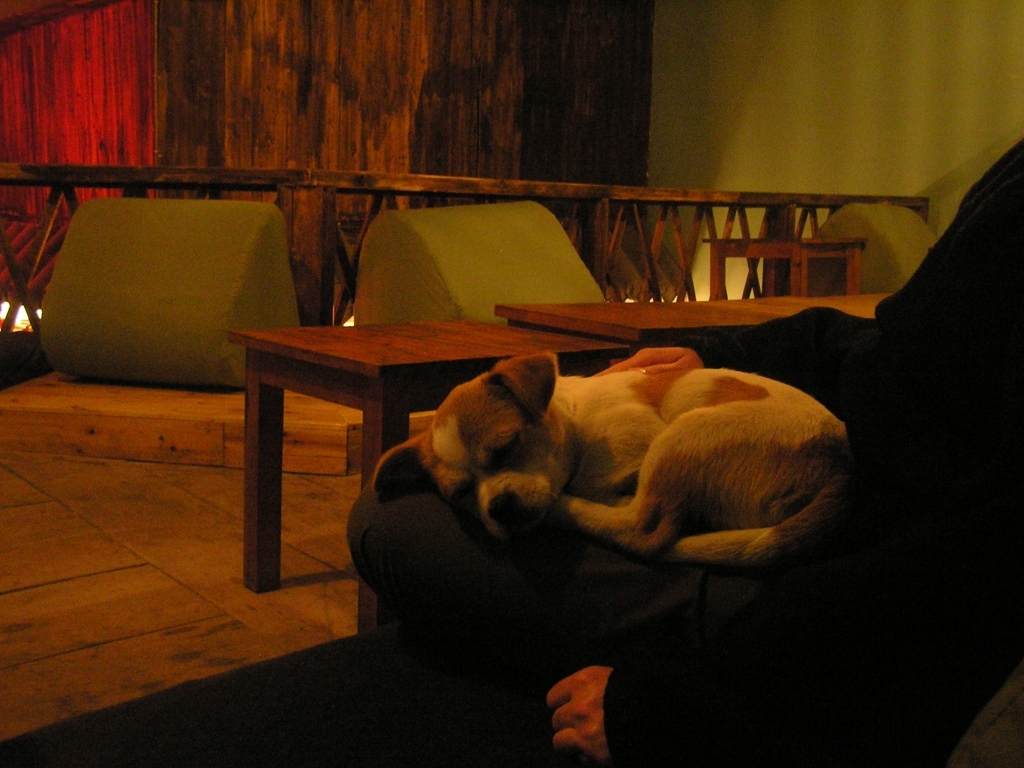Can you describe the lighting in the picture? The lighting in the picture is dim, with a warm glow that contributes to an intimate and relaxed atmosphere. There's a subtle interplay of light and shadows, highlighting the dog as the focal point of the photograph. Is there a specific mood or feeling conveyed by the image? The image conveys a sense of tranquility and warmth. The resting dog, soft lighting, and wooden decor create an inviting and serene environment, evoking feelings of comfort and relaxation. 